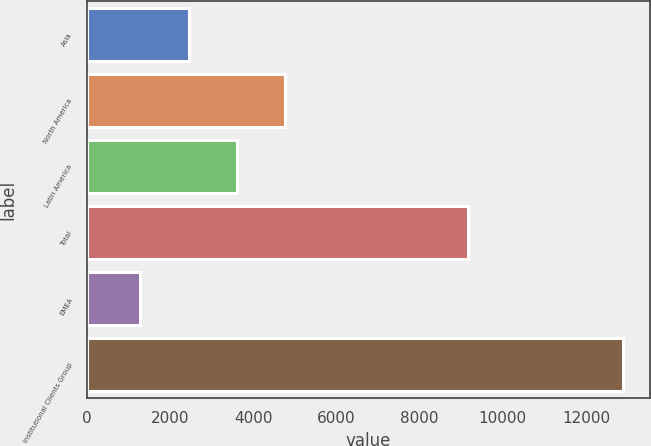Convert chart to OTSL. <chart><loc_0><loc_0><loc_500><loc_500><bar_chart><fcel>Asia<fcel>North America<fcel>Latin America<fcel>Total<fcel>EMEA<fcel>Institutional Clients Group<nl><fcel>2447.1<fcel>4767.3<fcel>3607.2<fcel>9152<fcel>1287<fcel>12888<nl></chart> 